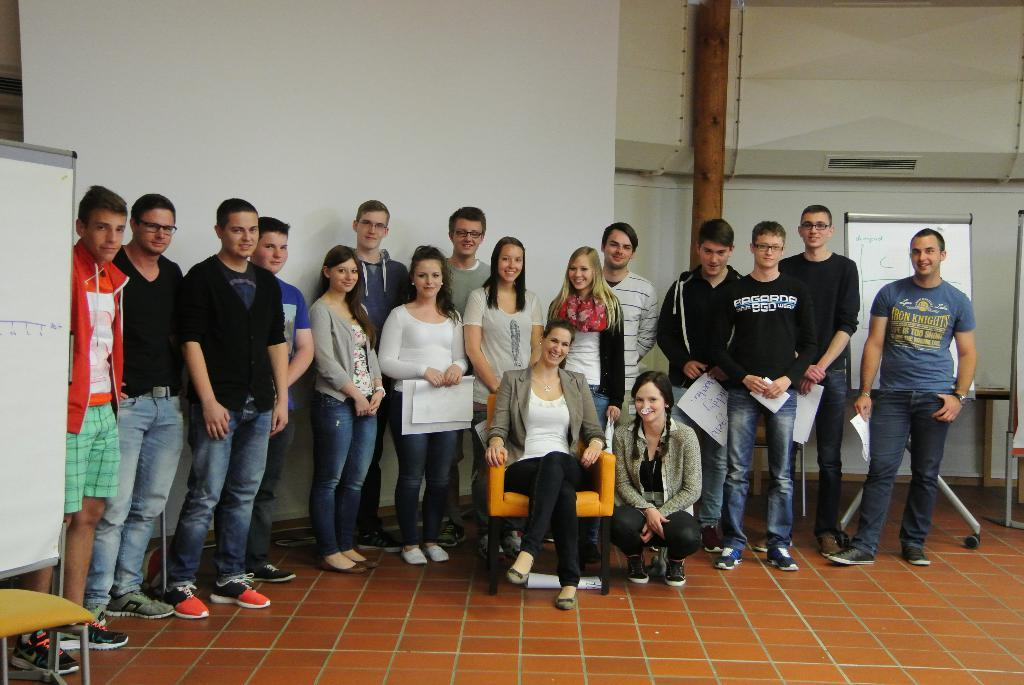What types of people are present in the image? There are men and women in the image. What are some of the people doing in the image? Some people are standing on the ground, and one person is sitting in a chair. What can be seen in the background of the image? There are pipelines and walls in the background of the image. What type of winter clothing can be seen on the people in the image? There is no mention of winter or winter clothing in the image; it does not depict a winter scene. 